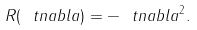Convert formula to latex. <formula><loc_0><loc_0><loc_500><loc_500>R ( \ t n a b l a ) = - \ t n a b l a ^ { 2 } .</formula> 